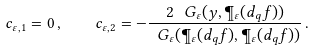<formula> <loc_0><loc_0><loc_500><loc_500>c _ { \varepsilon , 1 } = 0 \, , \quad c _ { \varepsilon , 2 } = - \frac { 2 \, \ G _ { \varepsilon } ( y , \P _ { \varepsilon } ( d _ { q } f ) ) } { \ G _ { \varepsilon } ( \P _ { \varepsilon } ( d _ { q } f ) , \P _ { \varepsilon } ( d _ { q } f ) ) } \, .</formula> 